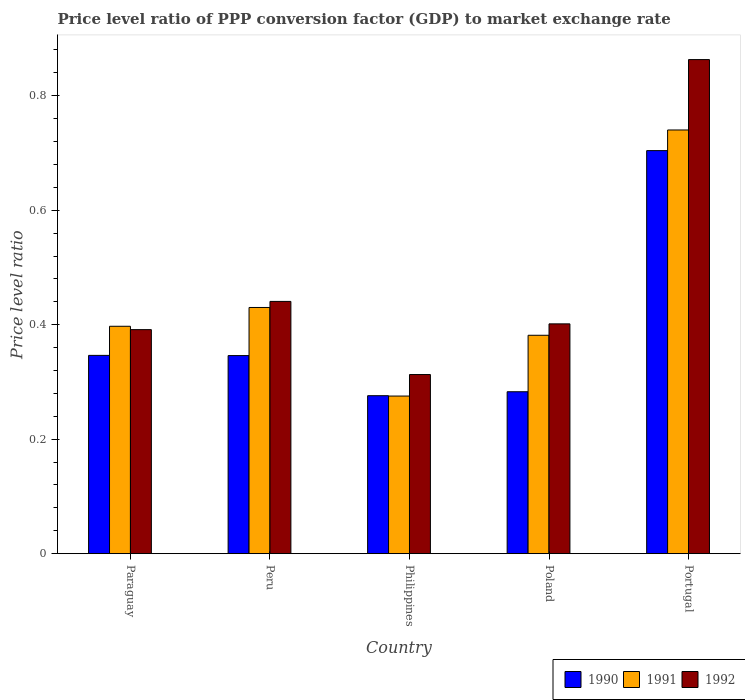How many groups of bars are there?
Keep it short and to the point. 5. How many bars are there on the 1st tick from the left?
Provide a short and direct response. 3. What is the label of the 2nd group of bars from the left?
Give a very brief answer. Peru. In how many cases, is the number of bars for a given country not equal to the number of legend labels?
Provide a short and direct response. 0. What is the price level ratio in 1991 in Paraguay?
Provide a succinct answer. 0.4. Across all countries, what is the maximum price level ratio in 1992?
Your response must be concise. 0.86. Across all countries, what is the minimum price level ratio in 1990?
Provide a succinct answer. 0.28. What is the total price level ratio in 1990 in the graph?
Keep it short and to the point. 1.96. What is the difference between the price level ratio in 1992 in Peru and that in Poland?
Provide a succinct answer. 0.04. What is the difference between the price level ratio in 1991 in Poland and the price level ratio in 1990 in Portugal?
Offer a terse response. -0.32. What is the average price level ratio in 1991 per country?
Provide a short and direct response. 0.44. What is the difference between the price level ratio of/in 1991 and price level ratio of/in 1992 in Peru?
Offer a very short reply. -0.01. What is the ratio of the price level ratio in 1991 in Philippines to that in Portugal?
Your response must be concise. 0.37. Is the price level ratio in 1990 in Paraguay less than that in Poland?
Ensure brevity in your answer.  No. Is the difference between the price level ratio in 1991 in Philippines and Portugal greater than the difference between the price level ratio in 1992 in Philippines and Portugal?
Provide a succinct answer. Yes. What is the difference between the highest and the second highest price level ratio in 1991?
Provide a short and direct response. 0.34. What is the difference between the highest and the lowest price level ratio in 1991?
Keep it short and to the point. 0.46. In how many countries, is the price level ratio in 1991 greater than the average price level ratio in 1991 taken over all countries?
Your answer should be very brief. 1. Is it the case that in every country, the sum of the price level ratio in 1991 and price level ratio in 1992 is greater than the price level ratio in 1990?
Offer a terse response. Yes. How many bars are there?
Provide a short and direct response. 15. Are the values on the major ticks of Y-axis written in scientific E-notation?
Your answer should be very brief. No. Does the graph contain any zero values?
Your response must be concise. No. Where does the legend appear in the graph?
Offer a terse response. Bottom right. How many legend labels are there?
Offer a very short reply. 3. How are the legend labels stacked?
Your answer should be very brief. Horizontal. What is the title of the graph?
Provide a succinct answer. Price level ratio of PPP conversion factor (GDP) to market exchange rate. Does "1994" appear as one of the legend labels in the graph?
Offer a very short reply. No. What is the label or title of the X-axis?
Offer a terse response. Country. What is the label or title of the Y-axis?
Keep it short and to the point. Price level ratio. What is the Price level ratio in 1990 in Paraguay?
Give a very brief answer. 0.35. What is the Price level ratio in 1991 in Paraguay?
Make the answer very short. 0.4. What is the Price level ratio in 1992 in Paraguay?
Keep it short and to the point. 0.39. What is the Price level ratio in 1990 in Peru?
Give a very brief answer. 0.35. What is the Price level ratio of 1991 in Peru?
Offer a terse response. 0.43. What is the Price level ratio of 1992 in Peru?
Give a very brief answer. 0.44. What is the Price level ratio of 1990 in Philippines?
Your response must be concise. 0.28. What is the Price level ratio of 1991 in Philippines?
Ensure brevity in your answer.  0.28. What is the Price level ratio of 1992 in Philippines?
Your answer should be compact. 0.31. What is the Price level ratio in 1990 in Poland?
Offer a terse response. 0.28. What is the Price level ratio in 1991 in Poland?
Your answer should be compact. 0.38. What is the Price level ratio of 1992 in Poland?
Keep it short and to the point. 0.4. What is the Price level ratio in 1990 in Portugal?
Ensure brevity in your answer.  0.7. What is the Price level ratio in 1991 in Portugal?
Give a very brief answer. 0.74. What is the Price level ratio in 1992 in Portugal?
Keep it short and to the point. 0.86. Across all countries, what is the maximum Price level ratio in 1990?
Your answer should be very brief. 0.7. Across all countries, what is the maximum Price level ratio in 1991?
Keep it short and to the point. 0.74. Across all countries, what is the maximum Price level ratio of 1992?
Give a very brief answer. 0.86. Across all countries, what is the minimum Price level ratio of 1990?
Keep it short and to the point. 0.28. Across all countries, what is the minimum Price level ratio in 1991?
Offer a very short reply. 0.28. Across all countries, what is the minimum Price level ratio in 1992?
Provide a short and direct response. 0.31. What is the total Price level ratio in 1990 in the graph?
Keep it short and to the point. 1.96. What is the total Price level ratio in 1991 in the graph?
Your answer should be very brief. 2.22. What is the total Price level ratio in 1992 in the graph?
Keep it short and to the point. 2.41. What is the difference between the Price level ratio in 1990 in Paraguay and that in Peru?
Offer a terse response. 0. What is the difference between the Price level ratio of 1991 in Paraguay and that in Peru?
Make the answer very short. -0.03. What is the difference between the Price level ratio of 1992 in Paraguay and that in Peru?
Your answer should be very brief. -0.05. What is the difference between the Price level ratio of 1990 in Paraguay and that in Philippines?
Your response must be concise. 0.07. What is the difference between the Price level ratio of 1991 in Paraguay and that in Philippines?
Your response must be concise. 0.12. What is the difference between the Price level ratio of 1992 in Paraguay and that in Philippines?
Ensure brevity in your answer.  0.08. What is the difference between the Price level ratio of 1990 in Paraguay and that in Poland?
Your response must be concise. 0.06. What is the difference between the Price level ratio in 1991 in Paraguay and that in Poland?
Provide a short and direct response. 0.02. What is the difference between the Price level ratio in 1992 in Paraguay and that in Poland?
Your answer should be compact. -0.01. What is the difference between the Price level ratio of 1990 in Paraguay and that in Portugal?
Make the answer very short. -0.36. What is the difference between the Price level ratio of 1991 in Paraguay and that in Portugal?
Ensure brevity in your answer.  -0.34. What is the difference between the Price level ratio of 1992 in Paraguay and that in Portugal?
Provide a short and direct response. -0.47. What is the difference between the Price level ratio of 1990 in Peru and that in Philippines?
Your answer should be very brief. 0.07. What is the difference between the Price level ratio in 1991 in Peru and that in Philippines?
Provide a short and direct response. 0.15. What is the difference between the Price level ratio in 1992 in Peru and that in Philippines?
Keep it short and to the point. 0.13. What is the difference between the Price level ratio of 1990 in Peru and that in Poland?
Your answer should be very brief. 0.06. What is the difference between the Price level ratio of 1991 in Peru and that in Poland?
Make the answer very short. 0.05. What is the difference between the Price level ratio of 1992 in Peru and that in Poland?
Your response must be concise. 0.04. What is the difference between the Price level ratio of 1990 in Peru and that in Portugal?
Keep it short and to the point. -0.36. What is the difference between the Price level ratio in 1991 in Peru and that in Portugal?
Your answer should be very brief. -0.31. What is the difference between the Price level ratio in 1992 in Peru and that in Portugal?
Your answer should be compact. -0.42. What is the difference between the Price level ratio of 1990 in Philippines and that in Poland?
Your answer should be compact. -0.01. What is the difference between the Price level ratio of 1991 in Philippines and that in Poland?
Ensure brevity in your answer.  -0.11. What is the difference between the Price level ratio in 1992 in Philippines and that in Poland?
Your answer should be very brief. -0.09. What is the difference between the Price level ratio of 1990 in Philippines and that in Portugal?
Your answer should be compact. -0.43. What is the difference between the Price level ratio of 1991 in Philippines and that in Portugal?
Your answer should be very brief. -0.46. What is the difference between the Price level ratio in 1992 in Philippines and that in Portugal?
Your response must be concise. -0.55. What is the difference between the Price level ratio of 1990 in Poland and that in Portugal?
Offer a very short reply. -0.42. What is the difference between the Price level ratio of 1991 in Poland and that in Portugal?
Your response must be concise. -0.36. What is the difference between the Price level ratio in 1992 in Poland and that in Portugal?
Your answer should be compact. -0.46. What is the difference between the Price level ratio in 1990 in Paraguay and the Price level ratio in 1991 in Peru?
Offer a very short reply. -0.08. What is the difference between the Price level ratio in 1990 in Paraguay and the Price level ratio in 1992 in Peru?
Provide a succinct answer. -0.09. What is the difference between the Price level ratio in 1991 in Paraguay and the Price level ratio in 1992 in Peru?
Keep it short and to the point. -0.04. What is the difference between the Price level ratio of 1990 in Paraguay and the Price level ratio of 1991 in Philippines?
Offer a terse response. 0.07. What is the difference between the Price level ratio of 1990 in Paraguay and the Price level ratio of 1992 in Philippines?
Your answer should be compact. 0.03. What is the difference between the Price level ratio in 1991 in Paraguay and the Price level ratio in 1992 in Philippines?
Provide a short and direct response. 0.08. What is the difference between the Price level ratio of 1990 in Paraguay and the Price level ratio of 1991 in Poland?
Provide a succinct answer. -0.04. What is the difference between the Price level ratio of 1990 in Paraguay and the Price level ratio of 1992 in Poland?
Make the answer very short. -0.06. What is the difference between the Price level ratio of 1991 in Paraguay and the Price level ratio of 1992 in Poland?
Your response must be concise. -0. What is the difference between the Price level ratio of 1990 in Paraguay and the Price level ratio of 1991 in Portugal?
Your answer should be compact. -0.39. What is the difference between the Price level ratio in 1990 in Paraguay and the Price level ratio in 1992 in Portugal?
Give a very brief answer. -0.52. What is the difference between the Price level ratio in 1991 in Paraguay and the Price level ratio in 1992 in Portugal?
Ensure brevity in your answer.  -0.47. What is the difference between the Price level ratio in 1990 in Peru and the Price level ratio in 1991 in Philippines?
Your answer should be compact. 0.07. What is the difference between the Price level ratio of 1990 in Peru and the Price level ratio of 1992 in Philippines?
Provide a short and direct response. 0.03. What is the difference between the Price level ratio of 1991 in Peru and the Price level ratio of 1992 in Philippines?
Your response must be concise. 0.12. What is the difference between the Price level ratio of 1990 in Peru and the Price level ratio of 1991 in Poland?
Keep it short and to the point. -0.04. What is the difference between the Price level ratio in 1990 in Peru and the Price level ratio in 1992 in Poland?
Make the answer very short. -0.06. What is the difference between the Price level ratio of 1991 in Peru and the Price level ratio of 1992 in Poland?
Give a very brief answer. 0.03. What is the difference between the Price level ratio of 1990 in Peru and the Price level ratio of 1991 in Portugal?
Keep it short and to the point. -0.39. What is the difference between the Price level ratio of 1990 in Peru and the Price level ratio of 1992 in Portugal?
Your response must be concise. -0.52. What is the difference between the Price level ratio of 1991 in Peru and the Price level ratio of 1992 in Portugal?
Your answer should be very brief. -0.43. What is the difference between the Price level ratio of 1990 in Philippines and the Price level ratio of 1991 in Poland?
Keep it short and to the point. -0.11. What is the difference between the Price level ratio of 1990 in Philippines and the Price level ratio of 1992 in Poland?
Offer a terse response. -0.13. What is the difference between the Price level ratio in 1991 in Philippines and the Price level ratio in 1992 in Poland?
Give a very brief answer. -0.13. What is the difference between the Price level ratio in 1990 in Philippines and the Price level ratio in 1991 in Portugal?
Provide a short and direct response. -0.46. What is the difference between the Price level ratio in 1990 in Philippines and the Price level ratio in 1992 in Portugal?
Your answer should be very brief. -0.59. What is the difference between the Price level ratio of 1991 in Philippines and the Price level ratio of 1992 in Portugal?
Your answer should be very brief. -0.59. What is the difference between the Price level ratio in 1990 in Poland and the Price level ratio in 1991 in Portugal?
Offer a very short reply. -0.46. What is the difference between the Price level ratio of 1990 in Poland and the Price level ratio of 1992 in Portugal?
Give a very brief answer. -0.58. What is the difference between the Price level ratio in 1991 in Poland and the Price level ratio in 1992 in Portugal?
Your answer should be compact. -0.48. What is the average Price level ratio in 1990 per country?
Give a very brief answer. 0.39. What is the average Price level ratio of 1991 per country?
Provide a succinct answer. 0.44. What is the average Price level ratio in 1992 per country?
Your answer should be compact. 0.48. What is the difference between the Price level ratio in 1990 and Price level ratio in 1991 in Paraguay?
Offer a terse response. -0.05. What is the difference between the Price level ratio in 1990 and Price level ratio in 1992 in Paraguay?
Offer a terse response. -0.04. What is the difference between the Price level ratio in 1991 and Price level ratio in 1992 in Paraguay?
Provide a succinct answer. 0.01. What is the difference between the Price level ratio of 1990 and Price level ratio of 1991 in Peru?
Your response must be concise. -0.08. What is the difference between the Price level ratio of 1990 and Price level ratio of 1992 in Peru?
Your response must be concise. -0.09. What is the difference between the Price level ratio in 1991 and Price level ratio in 1992 in Peru?
Your answer should be very brief. -0.01. What is the difference between the Price level ratio of 1990 and Price level ratio of 1991 in Philippines?
Give a very brief answer. 0. What is the difference between the Price level ratio of 1990 and Price level ratio of 1992 in Philippines?
Offer a very short reply. -0.04. What is the difference between the Price level ratio in 1991 and Price level ratio in 1992 in Philippines?
Your answer should be compact. -0.04. What is the difference between the Price level ratio in 1990 and Price level ratio in 1991 in Poland?
Provide a short and direct response. -0.1. What is the difference between the Price level ratio of 1990 and Price level ratio of 1992 in Poland?
Give a very brief answer. -0.12. What is the difference between the Price level ratio in 1991 and Price level ratio in 1992 in Poland?
Provide a short and direct response. -0.02. What is the difference between the Price level ratio of 1990 and Price level ratio of 1991 in Portugal?
Offer a terse response. -0.04. What is the difference between the Price level ratio in 1990 and Price level ratio in 1992 in Portugal?
Make the answer very short. -0.16. What is the difference between the Price level ratio in 1991 and Price level ratio in 1992 in Portugal?
Give a very brief answer. -0.12. What is the ratio of the Price level ratio of 1991 in Paraguay to that in Peru?
Offer a terse response. 0.92. What is the ratio of the Price level ratio in 1992 in Paraguay to that in Peru?
Provide a short and direct response. 0.89. What is the ratio of the Price level ratio in 1990 in Paraguay to that in Philippines?
Offer a terse response. 1.26. What is the ratio of the Price level ratio of 1991 in Paraguay to that in Philippines?
Keep it short and to the point. 1.44. What is the ratio of the Price level ratio in 1992 in Paraguay to that in Philippines?
Give a very brief answer. 1.25. What is the ratio of the Price level ratio in 1990 in Paraguay to that in Poland?
Ensure brevity in your answer.  1.22. What is the ratio of the Price level ratio in 1991 in Paraguay to that in Poland?
Keep it short and to the point. 1.04. What is the ratio of the Price level ratio in 1992 in Paraguay to that in Poland?
Provide a succinct answer. 0.97. What is the ratio of the Price level ratio of 1990 in Paraguay to that in Portugal?
Keep it short and to the point. 0.49. What is the ratio of the Price level ratio in 1991 in Paraguay to that in Portugal?
Give a very brief answer. 0.54. What is the ratio of the Price level ratio of 1992 in Paraguay to that in Portugal?
Provide a succinct answer. 0.45. What is the ratio of the Price level ratio in 1990 in Peru to that in Philippines?
Your answer should be very brief. 1.25. What is the ratio of the Price level ratio of 1991 in Peru to that in Philippines?
Make the answer very short. 1.56. What is the ratio of the Price level ratio of 1992 in Peru to that in Philippines?
Your answer should be very brief. 1.41. What is the ratio of the Price level ratio in 1990 in Peru to that in Poland?
Keep it short and to the point. 1.22. What is the ratio of the Price level ratio of 1991 in Peru to that in Poland?
Keep it short and to the point. 1.13. What is the ratio of the Price level ratio in 1992 in Peru to that in Poland?
Ensure brevity in your answer.  1.1. What is the ratio of the Price level ratio in 1990 in Peru to that in Portugal?
Keep it short and to the point. 0.49. What is the ratio of the Price level ratio of 1991 in Peru to that in Portugal?
Offer a terse response. 0.58. What is the ratio of the Price level ratio of 1992 in Peru to that in Portugal?
Give a very brief answer. 0.51. What is the ratio of the Price level ratio of 1990 in Philippines to that in Poland?
Keep it short and to the point. 0.98. What is the ratio of the Price level ratio in 1991 in Philippines to that in Poland?
Keep it short and to the point. 0.72. What is the ratio of the Price level ratio in 1992 in Philippines to that in Poland?
Give a very brief answer. 0.78. What is the ratio of the Price level ratio of 1990 in Philippines to that in Portugal?
Your response must be concise. 0.39. What is the ratio of the Price level ratio in 1991 in Philippines to that in Portugal?
Give a very brief answer. 0.37. What is the ratio of the Price level ratio of 1992 in Philippines to that in Portugal?
Your answer should be compact. 0.36. What is the ratio of the Price level ratio in 1990 in Poland to that in Portugal?
Your response must be concise. 0.4. What is the ratio of the Price level ratio in 1991 in Poland to that in Portugal?
Keep it short and to the point. 0.52. What is the ratio of the Price level ratio of 1992 in Poland to that in Portugal?
Provide a short and direct response. 0.47. What is the difference between the highest and the second highest Price level ratio of 1990?
Provide a short and direct response. 0.36. What is the difference between the highest and the second highest Price level ratio in 1991?
Offer a terse response. 0.31. What is the difference between the highest and the second highest Price level ratio in 1992?
Give a very brief answer. 0.42. What is the difference between the highest and the lowest Price level ratio of 1990?
Your answer should be very brief. 0.43. What is the difference between the highest and the lowest Price level ratio in 1991?
Provide a short and direct response. 0.46. What is the difference between the highest and the lowest Price level ratio of 1992?
Ensure brevity in your answer.  0.55. 